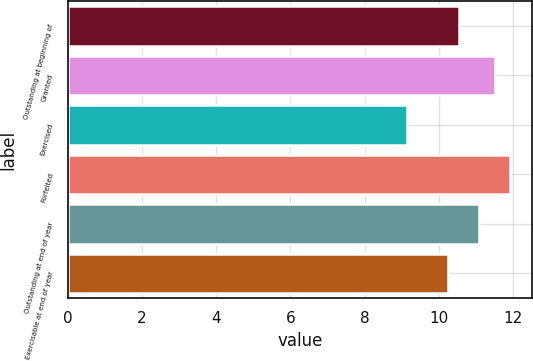Convert chart to OTSL. <chart><loc_0><loc_0><loc_500><loc_500><bar_chart><fcel>Outstanding at beginning of<fcel>Granted<fcel>Exercised<fcel>Forfeited<fcel>Outstanding at end of year<fcel>Exercisable at end of year<nl><fcel>10.54<fcel>11.52<fcel>9.15<fcel>11.91<fcel>11.07<fcel>10.25<nl></chart> 